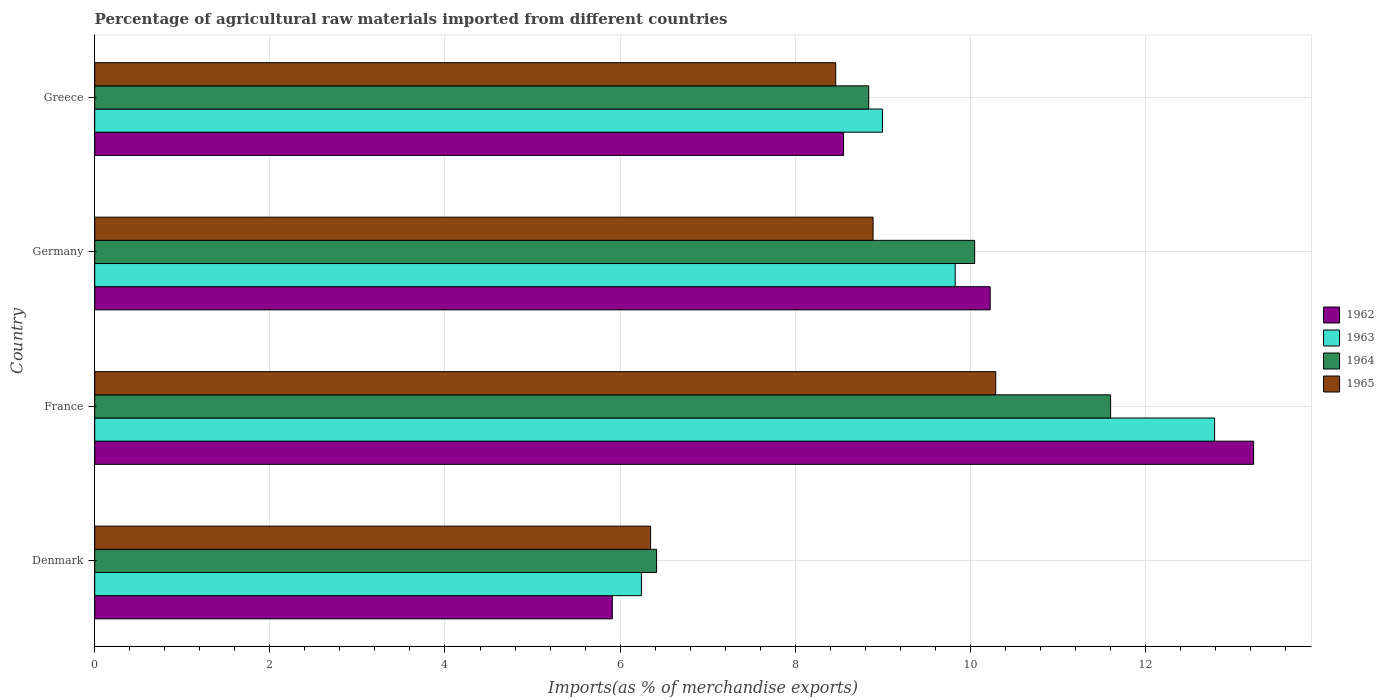Are the number of bars per tick equal to the number of legend labels?
Offer a very short reply. Yes. Are the number of bars on each tick of the Y-axis equal?
Your response must be concise. Yes. How many bars are there on the 4th tick from the top?
Give a very brief answer. 4. What is the label of the 1st group of bars from the top?
Provide a succinct answer. Greece. What is the percentage of imports to different countries in 1965 in France?
Ensure brevity in your answer.  10.29. Across all countries, what is the maximum percentage of imports to different countries in 1964?
Make the answer very short. 11.6. Across all countries, what is the minimum percentage of imports to different countries in 1963?
Provide a succinct answer. 6.24. What is the total percentage of imports to different countries in 1965 in the graph?
Your answer should be very brief. 33.99. What is the difference between the percentage of imports to different countries in 1963 in Denmark and that in Germany?
Offer a terse response. -3.58. What is the difference between the percentage of imports to different countries in 1962 in France and the percentage of imports to different countries in 1965 in Denmark?
Keep it short and to the point. 6.89. What is the average percentage of imports to different countries in 1962 per country?
Offer a terse response. 9.48. What is the difference between the percentage of imports to different countries in 1962 and percentage of imports to different countries in 1965 in Greece?
Your response must be concise. 0.09. In how many countries, is the percentage of imports to different countries in 1963 greater than 4.8 %?
Offer a very short reply. 4. What is the ratio of the percentage of imports to different countries in 1962 in Germany to that in Greece?
Your answer should be very brief. 1.2. Is the difference between the percentage of imports to different countries in 1962 in Denmark and France greater than the difference between the percentage of imports to different countries in 1965 in Denmark and France?
Give a very brief answer. No. What is the difference between the highest and the second highest percentage of imports to different countries in 1965?
Keep it short and to the point. 1.4. What is the difference between the highest and the lowest percentage of imports to different countries in 1965?
Your answer should be very brief. 3.94. Is the sum of the percentage of imports to different countries in 1962 in Denmark and Germany greater than the maximum percentage of imports to different countries in 1963 across all countries?
Give a very brief answer. Yes. What does the 2nd bar from the top in Denmark represents?
Your response must be concise. 1964. What does the 3rd bar from the bottom in Greece represents?
Give a very brief answer. 1964. How many bars are there?
Keep it short and to the point. 16. How many countries are there in the graph?
Your answer should be compact. 4. What is the difference between two consecutive major ticks on the X-axis?
Keep it short and to the point. 2. Are the values on the major ticks of X-axis written in scientific E-notation?
Make the answer very short. No. Does the graph contain any zero values?
Keep it short and to the point. No. Where does the legend appear in the graph?
Provide a succinct answer. Center right. How are the legend labels stacked?
Make the answer very short. Vertical. What is the title of the graph?
Give a very brief answer. Percentage of agricultural raw materials imported from different countries. What is the label or title of the X-axis?
Keep it short and to the point. Imports(as % of merchandise exports). What is the label or title of the Y-axis?
Offer a very short reply. Country. What is the Imports(as % of merchandise exports) in 1962 in Denmark?
Keep it short and to the point. 5.91. What is the Imports(as % of merchandise exports) in 1963 in Denmark?
Offer a terse response. 6.24. What is the Imports(as % of merchandise exports) in 1964 in Denmark?
Ensure brevity in your answer.  6.42. What is the Imports(as % of merchandise exports) of 1965 in Denmark?
Offer a terse response. 6.35. What is the Imports(as % of merchandise exports) in 1962 in France?
Give a very brief answer. 13.24. What is the Imports(as % of merchandise exports) of 1963 in France?
Offer a very short reply. 12.79. What is the Imports(as % of merchandise exports) in 1964 in France?
Keep it short and to the point. 11.6. What is the Imports(as % of merchandise exports) in 1965 in France?
Keep it short and to the point. 10.29. What is the Imports(as % of merchandise exports) in 1962 in Germany?
Provide a short and direct response. 10.23. What is the Imports(as % of merchandise exports) in 1963 in Germany?
Ensure brevity in your answer.  9.83. What is the Imports(as % of merchandise exports) in 1964 in Germany?
Ensure brevity in your answer.  10.05. What is the Imports(as % of merchandise exports) of 1965 in Germany?
Give a very brief answer. 8.89. What is the Imports(as % of merchandise exports) of 1962 in Greece?
Offer a terse response. 8.55. What is the Imports(as % of merchandise exports) in 1963 in Greece?
Offer a very short reply. 9. What is the Imports(as % of merchandise exports) in 1964 in Greece?
Keep it short and to the point. 8.84. What is the Imports(as % of merchandise exports) of 1965 in Greece?
Provide a short and direct response. 8.46. Across all countries, what is the maximum Imports(as % of merchandise exports) in 1962?
Provide a short and direct response. 13.24. Across all countries, what is the maximum Imports(as % of merchandise exports) of 1963?
Your answer should be compact. 12.79. Across all countries, what is the maximum Imports(as % of merchandise exports) in 1964?
Keep it short and to the point. 11.6. Across all countries, what is the maximum Imports(as % of merchandise exports) of 1965?
Keep it short and to the point. 10.29. Across all countries, what is the minimum Imports(as % of merchandise exports) of 1962?
Your answer should be very brief. 5.91. Across all countries, what is the minimum Imports(as % of merchandise exports) of 1963?
Ensure brevity in your answer.  6.24. Across all countries, what is the minimum Imports(as % of merchandise exports) in 1964?
Give a very brief answer. 6.42. Across all countries, what is the minimum Imports(as % of merchandise exports) in 1965?
Ensure brevity in your answer.  6.35. What is the total Imports(as % of merchandise exports) in 1962 in the graph?
Make the answer very short. 37.93. What is the total Imports(as % of merchandise exports) in 1963 in the graph?
Keep it short and to the point. 37.86. What is the total Imports(as % of merchandise exports) in 1964 in the graph?
Ensure brevity in your answer.  36.91. What is the total Imports(as % of merchandise exports) of 1965 in the graph?
Give a very brief answer. 33.99. What is the difference between the Imports(as % of merchandise exports) in 1962 in Denmark and that in France?
Provide a short and direct response. -7.32. What is the difference between the Imports(as % of merchandise exports) in 1963 in Denmark and that in France?
Your answer should be compact. -6.55. What is the difference between the Imports(as % of merchandise exports) of 1964 in Denmark and that in France?
Keep it short and to the point. -5.19. What is the difference between the Imports(as % of merchandise exports) in 1965 in Denmark and that in France?
Your answer should be compact. -3.94. What is the difference between the Imports(as % of merchandise exports) in 1962 in Denmark and that in Germany?
Offer a terse response. -4.32. What is the difference between the Imports(as % of merchandise exports) of 1963 in Denmark and that in Germany?
Give a very brief answer. -3.58. What is the difference between the Imports(as % of merchandise exports) in 1964 in Denmark and that in Germany?
Your answer should be very brief. -3.63. What is the difference between the Imports(as % of merchandise exports) in 1965 in Denmark and that in Germany?
Give a very brief answer. -2.54. What is the difference between the Imports(as % of merchandise exports) of 1962 in Denmark and that in Greece?
Ensure brevity in your answer.  -2.64. What is the difference between the Imports(as % of merchandise exports) in 1963 in Denmark and that in Greece?
Keep it short and to the point. -2.75. What is the difference between the Imports(as % of merchandise exports) in 1964 in Denmark and that in Greece?
Offer a very short reply. -2.42. What is the difference between the Imports(as % of merchandise exports) in 1965 in Denmark and that in Greece?
Make the answer very short. -2.11. What is the difference between the Imports(as % of merchandise exports) of 1962 in France and that in Germany?
Provide a succinct answer. 3.01. What is the difference between the Imports(as % of merchandise exports) in 1963 in France and that in Germany?
Your answer should be very brief. 2.96. What is the difference between the Imports(as % of merchandise exports) in 1964 in France and that in Germany?
Give a very brief answer. 1.55. What is the difference between the Imports(as % of merchandise exports) of 1965 in France and that in Germany?
Provide a short and direct response. 1.4. What is the difference between the Imports(as % of merchandise exports) in 1962 in France and that in Greece?
Give a very brief answer. 4.68. What is the difference between the Imports(as % of merchandise exports) in 1963 in France and that in Greece?
Offer a terse response. 3.79. What is the difference between the Imports(as % of merchandise exports) in 1964 in France and that in Greece?
Provide a short and direct response. 2.76. What is the difference between the Imports(as % of merchandise exports) of 1965 in France and that in Greece?
Your response must be concise. 1.83. What is the difference between the Imports(as % of merchandise exports) in 1962 in Germany and that in Greece?
Offer a terse response. 1.67. What is the difference between the Imports(as % of merchandise exports) of 1963 in Germany and that in Greece?
Give a very brief answer. 0.83. What is the difference between the Imports(as % of merchandise exports) in 1964 in Germany and that in Greece?
Offer a very short reply. 1.21. What is the difference between the Imports(as % of merchandise exports) of 1965 in Germany and that in Greece?
Make the answer very short. 0.43. What is the difference between the Imports(as % of merchandise exports) in 1962 in Denmark and the Imports(as % of merchandise exports) in 1963 in France?
Your answer should be compact. -6.88. What is the difference between the Imports(as % of merchandise exports) of 1962 in Denmark and the Imports(as % of merchandise exports) of 1964 in France?
Your answer should be compact. -5.69. What is the difference between the Imports(as % of merchandise exports) of 1962 in Denmark and the Imports(as % of merchandise exports) of 1965 in France?
Ensure brevity in your answer.  -4.38. What is the difference between the Imports(as % of merchandise exports) of 1963 in Denmark and the Imports(as % of merchandise exports) of 1964 in France?
Ensure brevity in your answer.  -5.36. What is the difference between the Imports(as % of merchandise exports) of 1963 in Denmark and the Imports(as % of merchandise exports) of 1965 in France?
Give a very brief answer. -4.05. What is the difference between the Imports(as % of merchandise exports) of 1964 in Denmark and the Imports(as % of merchandise exports) of 1965 in France?
Ensure brevity in your answer.  -3.87. What is the difference between the Imports(as % of merchandise exports) in 1962 in Denmark and the Imports(as % of merchandise exports) in 1963 in Germany?
Your response must be concise. -3.92. What is the difference between the Imports(as % of merchandise exports) of 1962 in Denmark and the Imports(as % of merchandise exports) of 1964 in Germany?
Provide a succinct answer. -4.14. What is the difference between the Imports(as % of merchandise exports) in 1962 in Denmark and the Imports(as % of merchandise exports) in 1965 in Germany?
Provide a succinct answer. -2.98. What is the difference between the Imports(as % of merchandise exports) in 1963 in Denmark and the Imports(as % of merchandise exports) in 1964 in Germany?
Offer a very short reply. -3.81. What is the difference between the Imports(as % of merchandise exports) in 1963 in Denmark and the Imports(as % of merchandise exports) in 1965 in Germany?
Your response must be concise. -2.65. What is the difference between the Imports(as % of merchandise exports) of 1964 in Denmark and the Imports(as % of merchandise exports) of 1965 in Germany?
Offer a very short reply. -2.47. What is the difference between the Imports(as % of merchandise exports) in 1962 in Denmark and the Imports(as % of merchandise exports) in 1963 in Greece?
Your answer should be very brief. -3.08. What is the difference between the Imports(as % of merchandise exports) in 1962 in Denmark and the Imports(as % of merchandise exports) in 1964 in Greece?
Give a very brief answer. -2.93. What is the difference between the Imports(as % of merchandise exports) in 1962 in Denmark and the Imports(as % of merchandise exports) in 1965 in Greece?
Give a very brief answer. -2.55. What is the difference between the Imports(as % of merchandise exports) of 1963 in Denmark and the Imports(as % of merchandise exports) of 1964 in Greece?
Your answer should be very brief. -2.6. What is the difference between the Imports(as % of merchandise exports) in 1963 in Denmark and the Imports(as % of merchandise exports) in 1965 in Greece?
Keep it short and to the point. -2.22. What is the difference between the Imports(as % of merchandise exports) in 1964 in Denmark and the Imports(as % of merchandise exports) in 1965 in Greece?
Offer a terse response. -2.05. What is the difference between the Imports(as % of merchandise exports) of 1962 in France and the Imports(as % of merchandise exports) of 1963 in Germany?
Ensure brevity in your answer.  3.41. What is the difference between the Imports(as % of merchandise exports) in 1962 in France and the Imports(as % of merchandise exports) in 1964 in Germany?
Make the answer very short. 3.19. What is the difference between the Imports(as % of merchandise exports) of 1962 in France and the Imports(as % of merchandise exports) of 1965 in Germany?
Your answer should be compact. 4.35. What is the difference between the Imports(as % of merchandise exports) in 1963 in France and the Imports(as % of merchandise exports) in 1964 in Germany?
Your answer should be compact. 2.74. What is the difference between the Imports(as % of merchandise exports) of 1963 in France and the Imports(as % of merchandise exports) of 1965 in Germany?
Your answer should be very brief. 3.9. What is the difference between the Imports(as % of merchandise exports) of 1964 in France and the Imports(as % of merchandise exports) of 1965 in Germany?
Provide a short and direct response. 2.71. What is the difference between the Imports(as % of merchandise exports) of 1962 in France and the Imports(as % of merchandise exports) of 1963 in Greece?
Provide a short and direct response. 4.24. What is the difference between the Imports(as % of merchandise exports) in 1962 in France and the Imports(as % of merchandise exports) in 1964 in Greece?
Your answer should be very brief. 4.4. What is the difference between the Imports(as % of merchandise exports) of 1962 in France and the Imports(as % of merchandise exports) of 1965 in Greece?
Your answer should be very brief. 4.77. What is the difference between the Imports(as % of merchandise exports) of 1963 in France and the Imports(as % of merchandise exports) of 1964 in Greece?
Make the answer very short. 3.95. What is the difference between the Imports(as % of merchandise exports) in 1963 in France and the Imports(as % of merchandise exports) in 1965 in Greece?
Your answer should be compact. 4.33. What is the difference between the Imports(as % of merchandise exports) of 1964 in France and the Imports(as % of merchandise exports) of 1965 in Greece?
Your answer should be compact. 3.14. What is the difference between the Imports(as % of merchandise exports) in 1962 in Germany and the Imports(as % of merchandise exports) in 1963 in Greece?
Your response must be concise. 1.23. What is the difference between the Imports(as % of merchandise exports) of 1962 in Germany and the Imports(as % of merchandise exports) of 1964 in Greece?
Give a very brief answer. 1.39. What is the difference between the Imports(as % of merchandise exports) in 1962 in Germany and the Imports(as % of merchandise exports) in 1965 in Greece?
Provide a short and direct response. 1.76. What is the difference between the Imports(as % of merchandise exports) in 1963 in Germany and the Imports(as % of merchandise exports) in 1964 in Greece?
Give a very brief answer. 0.99. What is the difference between the Imports(as % of merchandise exports) of 1963 in Germany and the Imports(as % of merchandise exports) of 1965 in Greece?
Give a very brief answer. 1.36. What is the difference between the Imports(as % of merchandise exports) of 1964 in Germany and the Imports(as % of merchandise exports) of 1965 in Greece?
Offer a very short reply. 1.59. What is the average Imports(as % of merchandise exports) of 1962 per country?
Give a very brief answer. 9.48. What is the average Imports(as % of merchandise exports) of 1963 per country?
Ensure brevity in your answer.  9.46. What is the average Imports(as % of merchandise exports) in 1964 per country?
Keep it short and to the point. 9.23. What is the average Imports(as % of merchandise exports) of 1965 per country?
Ensure brevity in your answer.  8.5. What is the difference between the Imports(as % of merchandise exports) in 1962 and Imports(as % of merchandise exports) in 1963 in Denmark?
Your response must be concise. -0.33. What is the difference between the Imports(as % of merchandise exports) in 1962 and Imports(as % of merchandise exports) in 1964 in Denmark?
Your answer should be very brief. -0.51. What is the difference between the Imports(as % of merchandise exports) of 1962 and Imports(as % of merchandise exports) of 1965 in Denmark?
Offer a terse response. -0.44. What is the difference between the Imports(as % of merchandise exports) in 1963 and Imports(as % of merchandise exports) in 1964 in Denmark?
Offer a very short reply. -0.17. What is the difference between the Imports(as % of merchandise exports) of 1963 and Imports(as % of merchandise exports) of 1965 in Denmark?
Your answer should be very brief. -0.1. What is the difference between the Imports(as % of merchandise exports) in 1964 and Imports(as % of merchandise exports) in 1965 in Denmark?
Provide a succinct answer. 0.07. What is the difference between the Imports(as % of merchandise exports) in 1962 and Imports(as % of merchandise exports) in 1963 in France?
Provide a short and direct response. 0.45. What is the difference between the Imports(as % of merchandise exports) of 1962 and Imports(as % of merchandise exports) of 1964 in France?
Provide a succinct answer. 1.63. What is the difference between the Imports(as % of merchandise exports) of 1962 and Imports(as % of merchandise exports) of 1965 in France?
Keep it short and to the point. 2.95. What is the difference between the Imports(as % of merchandise exports) in 1963 and Imports(as % of merchandise exports) in 1964 in France?
Provide a succinct answer. 1.19. What is the difference between the Imports(as % of merchandise exports) of 1963 and Imports(as % of merchandise exports) of 1965 in France?
Your answer should be very brief. 2.5. What is the difference between the Imports(as % of merchandise exports) of 1964 and Imports(as % of merchandise exports) of 1965 in France?
Offer a terse response. 1.31. What is the difference between the Imports(as % of merchandise exports) of 1962 and Imports(as % of merchandise exports) of 1963 in Germany?
Ensure brevity in your answer.  0.4. What is the difference between the Imports(as % of merchandise exports) in 1962 and Imports(as % of merchandise exports) in 1964 in Germany?
Your answer should be compact. 0.18. What is the difference between the Imports(as % of merchandise exports) of 1962 and Imports(as % of merchandise exports) of 1965 in Germany?
Your answer should be very brief. 1.34. What is the difference between the Imports(as % of merchandise exports) in 1963 and Imports(as % of merchandise exports) in 1964 in Germany?
Offer a terse response. -0.22. What is the difference between the Imports(as % of merchandise exports) in 1963 and Imports(as % of merchandise exports) in 1965 in Germany?
Keep it short and to the point. 0.94. What is the difference between the Imports(as % of merchandise exports) in 1964 and Imports(as % of merchandise exports) in 1965 in Germany?
Make the answer very short. 1.16. What is the difference between the Imports(as % of merchandise exports) in 1962 and Imports(as % of merchandise exports) in 1963 in Greece?
Offer a very short reply. -0.44. What is the difference between the Imports(as % of merchandise exports) in 1962 and Imports(as % of merchandise exports) in 1964 in Greece?
Offer a terse response. -0.29. What is the difference between the Imports(as % of merchandise exports) of 1962 and Imports(as % of merchandise exports) of 1965 in Greece?
Give a very brief answer. 0.09. What is the difference between the Imports(as % of merchandise exports) of 1963 and Imports(as % of merchandise exports) of 1964 in Greece?
Your response must be concise. 0.16. What is the difference between the Imports(as % of merchandise exports) of 1963 and Imports(as % of merchandise exports) of 1965 in Greece?
Provide a short and direct response. 0.53. What is the difference between the Imports(as % of merchandise exports) of 1964 and Imports(as % of merchandise exports) of 1965 in Greece?
Your answer should be very brief. 0.38. What is the ratio of the Imports(as % of merchandise exports) of 1962 in Denmark to that in France?
Your answer should be compact. 0.45. What is the ratio of the Imports(as % of merchandise exports) of 1963 in Denmark to that in France?
Keep it short and to the point. 0.49. What is the ratio of the Imports(as % of merchandise exports) of 1964 in Denmark to that in France?
Keep it short and to the point. 0.55. What is the ratio of the Imports(as % of merchandise exports) in 1965 in Denmark to that in France?
Offer a terse response. 0.62. What is the ratio of the Imports(as % of merchandise exports) in 1962 in Denmark to that in Germany?
Make the answer very short. 0.58. What is the ratio of the Imports(as % of merchandise exports) in 1963 in Denmark to that in Germany?
Make the answer very short. 0.64. What is the ratio of the Imports(as % of merchandise exports) of 1964 in Denmark to that in Germany?
Your answer should be compact. 0.64. What is the ratio of the Imports(as % of merchandise exports) of 1965 in Denmark to that in Germany?
Offer a terse response. 0.71. What is the ratio of the Imports(as % of merchandise exports) in 1962 in Denmark to that in Greece?
Ensure brevity in your answer.  0.69. What is the ratio of the Imports(as % of merchandise exports) in 1963 in Denmark to that in Greece?
Keep it short and to the point. 0.69. What is the ratio of the Imports(as % of merchandise exports) of 1964 in Denmark to that in Greece?
Offer a terse response. 0.73. What is the ratio of the Imports(as % of merchandise exports) in 1965 in Denmark to that in Greece?
Make the answer very short. 0.75. What is the ratio of the Imports(as % of merchandise exports) of 1962 in France to that in Germany?
Keep it short and to the point. 1.29. What is the ratio of the Imports(as % of merchandise exports) of 1963 in France to that in Germany?
Your answer should be very brief. 1.3. What is the ratio of the Imports(as % of merchandise exports) of 1964 in France to that in Germany?
Your answer should be compact. 1.15. What is the ratio of the Imports(as % of merchandise exports) of 1965 in France to that in Germany?
Ensure brevity in your answer.  1.16. What is the ratio of the Imports(as % of merchandise exports) of 1962 in France to that in Greece?
Your answer should be compact. 1.55. What is the ratio of the Imports(as % of merchandise exports) of 1963 in France to that in Greece?
Provide a succinct answer. 1.42. What is the ratio of the Imports(as % of merchandise exports) of 1964 in France to that in Greece?
Provide a succinct answer. 1.31. What is the ratio of the Imports(as % of merchandise exports) of 1965 in France to that in Greece?
Offer a terse response. 1.22. What is the ratio of the Imports(as % of merchandise exports) in 1962 in Germany to that in Greece?
Your response must be concise. 1.2. What is the ratio of the Imports(as % of merchandise exports) in 1963 in Germany to that in Greece?
Give a very brief answer. 1.09. What is the ratio of the Imports(as % of merchandise exports) in 1964 in Germany to that in Greece?
Your answer should be very brief. 1.14. What is the ratio of the Imports(as % of merchandise exports) in 1965 in Germany to that in Greece?
Your response must be concise. 1.05. What is the difference between the highest and the second highest Imports(as % of merchandise exports) in 1962?
Provide a succinct answer. 3.01. What is the difference between the highest and the second highest Imports(as % of merchandise exports) of 1963?
Make the answer very short. 2.96. What is the difference between the highest and the second highest Imports(as % of merchandise exports) in 1964?
Provide a succinct answer. 1.55. What is the difference between the highest and the second highest Imports(as % of merchandise exports) in 1965?
Ensure brevity in your answer.  1.4. What is the difference between the highest and the lowest Imports(as % of merchandise exports) of 1962?
Give a very brief answer. 7.32. What is the difference between the highest and the lowest Imports(as % of merchandise exports) of 1963?
Your response must be concise. 6.55. What is the difference between the highest and the lowest Imports(as % of merchandise exports) in 1964?
Provide a short and direct response. 5.19. What is the difference between the highest and the lowest Imports(as % of merchandise exports) in 1965?
Ensure brevity in your answer.  3.94. 